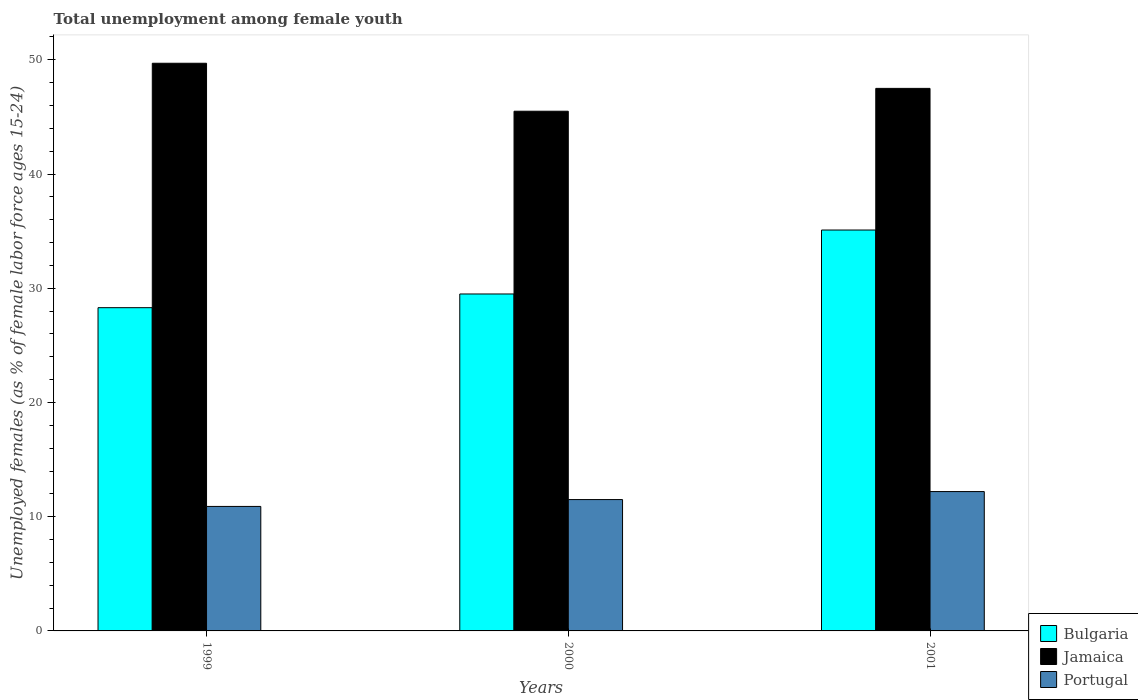How many different coloured bars are there?
Give a very brief answer. 3. Are the number of bars per tick equal to the number of legend labels?
Ensure brevity in your answer.  Yes. Are the number of bars on each tick of the X-axis equal?
Give a very brief answer. Yes. How many bars are there on the 2nd tick from the left?
Provide a short and direct response. 3. How many bars are there on the 1st tick from the right?
Your response must be concise. 3. In how many cases, is the number of bars for a given year not equal to the number of legend labels?
Your response must be concise. 0. What is the percentage of unemployed females in in Bulgaria in 2001?
Provide a short and direct response. 35.1. Across all years, what is the maximum percentage of unemployed females in in Bulgaria?
Your response must be concise. 35.1. Across all years, what is the minimum percentage of unemployed females in in Portugal?
Keep it short and to the point. 10.9. In which year was the percentage of unemployed females in in Jamaica maximum?
Offer a terse response. 1999. What is the total percentage of unemployed females in in Bulgaria in the graph?
Your response must be concise. 92.9. What is the difference between the percentage of unemployed females in in Portugal in 2000 and that in 2001?
Your answer should be compact. -0.7. What is the difference between the percentage of unemployed females in in Jamaica in 2000 and the percentage of unemployed females in in Bulgaria in 2001?
Provide a short and direct response. 10.4. What is the average percentage of unemployed females in in Portugal per year?
Keep it short and to the point. 11.53. In the year 2001, what is the difference between the percentage of unemployed females in in Bulgaria and percentage of unemployed females in in Jamaica?
Give a very brief answer. -12.4. What is the ratio of the percentage of unemployed females in in Bulgaria in 2000 to that in 2001?
Your answer should be very brief. 0.84. Is the percentage of unemployed females in in Portugal in 1999 less than that in 2000?
Offer a very short reply. Yes. What is the difference between the highest and the second highest percentage of unemployed females in in Bulgaria?
Your response must be concise. 5.6. What is the difference between the highest and the lowest percentage of unemployed females in in Portugal?
Provide a succinct answer. 1.3. In how many years, is the percentage of unemployed females in in Jamaica greater than the average percentage of unemployed females in in Jamaica taken over all years?
Provide a short and direct response. 1. Does the graph contain any zero values?
Your answer should be compact. No. Where does the legend appear in the graph?
Your response must be concise. Bottom right. How are the legend labels stacked?
Your response must be concise. Vertical. What is the title of the graph?
Provide a succinct answer. Total unemployment among female youth. Does "El Salvador" appear as one of the legend labels in the graph?
Provide a succinct answer. No. What is the label or title of the X-axis?
Your answer should be very brief. Years. What is the label or title of the Y-axis?
Provide a succinct answer. Unemployed females (as % of female labor force ages 15-24). What is the Unemployed females (as % of female labor force ages 15-24) in Bulgaria in 1999?
Your response must be concise. 28.3. What is the Unemployed females (as % of female labor force ages 15-24) in Jamaica in 1999?
Provide a succinct answer. 49.7. What is the Unemployed females (as % of female labor force ages 15-24) in Portugal in 1999?
Offer a very short reply. 10.9. What is the Unemployed females (as % of female labor force ages 15-24) of Bulgaria in 2000?
Provide a succinct answer. 29.5. What is the Unemployed females (as % of female labor force ages 15-24) in Jamaica in 2000?
Your response must be concise. 45.5. What is the Unemployed females (as % of female labor force ages 15-24) in Bulgaria in 2001?
Offer a very short reply. 35.1. What is the Unemployed females (as % of female labor force ages 15-24) of Jamaica in 2001?
Your answer should be very brief. 47.5. What is the Unemployed females (as % of female labor force ages 15-24) in Portugal in 2001?
Offer a very short reply. 12.2. Across all years, what is the maximum Unemployed females (as % of female labor force ages 15-24) in Bulgaria?
Ensure brevity in your answer.  35.1. Across all years, what is the maximum Unemployed females (as % of female labor force ages 15-24) of Jamaica?
Offer a terse response. 49.7. Across all years, what is the maximum Unemployed females (as % of female labor force ages 15-24) of Portugal?
Your response must be concise. 12.2. Across all years, what is the minimum Unemployed females (as % of female labor force ages 15-24) of Bulgaria?
Offer a terse response. 28.3. Across all years, what is the minimum Unemployed females (as % of female labor force ages 15-24) in Jamaica?
Keep it short and to the point. 45.5. Across all years, what is the minimum Unemployed females (as % of female labor force ages 15-24) of Portugal?
Offer a very short reply. 10.9. What is the total Unemployed females (as % of female labor force ages 15-24) of Bulgaria in the graph?
Provide a succinct answer. 92.9. What is the total Unemployed females (as % of female labor force ages 15-24) in Jamaica in the graph?
Give a very brief answer. 142.7. What is the total Unemployed females (as % of female labor force ages 15-24) in Portugal in the graph?
Make the answer very short. 34.6. What is the difference between the Unemployed females (as % of female labor force ages 15-24) in Jamaica in 1999 and that in 2000?
Make the answer very short. 4.2. What is the difference between the Unemployed females (as % of female labor force ages 15-24) in Portugal in 1999 and that in 2000?
Provide a succinct answer. -0.6. What is the difference between the Unemployed females (as % of female labor force ages 15-24) of Bulgaria in 2000 and that in 2001?
Make the answer very short. -5.6. What is the difference between the Unemployed females (as % of female labor force ages 15-24) in Jamaica in 2000 and that in 2001?
Your response must be concise. -2. What is the difference between the Unemployed females (as % of female labor force ages 15-24) in Bulgaria in 1999 and the Unemployed females (as % of female labor force ages 15-24) in Jamaica in 2000?
Keep it short and to the point. -17.2. What is the difference between the Unemployed females (as % of female labor force ages 15-24) of Jamaica in 1999 and the Unemployed females (as % of female labor force ages 15-24) of Portugal in 2000?
Your answer should be very brief. 38.2. What is the difference between the Unemployed females (as % of female labor force ages 15-24) of Bulgaria in 1999 and the Unemployed females (as % of female labor force ages 15-24) of Jamaica in 2001?
Make the answer very short. -19.2. What is the difference between the Unemployed females (as % of female labor force ages 15-24) of Jamaica in 1999 and the Unemployed females (as % of female labor force ages 15-24) of Portugal in 2001?
Keep it short and to the point. 37.5. What is the difference between the Unemployed females (as % of female labor force ages 15-24) of Bulgaria in 2000 and the Unemployed females (as % of female labor force ages 15-24) of Jamaica in 2001?
Ensure brevity in your answer.  -18. What is the difference between the Unemployed females (as % of female labor force ages 15-24) of Jamaica in 2000 and the Unemployed females (as % of female labor force ages 15-24) of Portugal in 2001?
Offer a terse response. 33.3. What is the average Unemployed females (as % of female labor force ages 15-24) of Bulgaria per year?
Make the answer very short. 30.97. What is the average Unemployed females (as % of female labor force ages 15-24) in Jamaica per year?
Make the answer very short. 47.57. What is the average Unemployed females (as % of female labor force ages 15-24) of Portugal per year?
Provide a succinct answer. 11.53. In the year 1999, what is the difference between the Unemployed females (as % of female labor force ages 15-24) of Bulgaria and Unemployed females (as % of female labor force ages 15-24) of Jamaica?
Provide a short and direct response. -21.4. In the year 1999, what is the difference between the Unemployed females (as % of female labor force ages 15-24) in Jamaica and Unemployed females (as % of female labor force ages 15-24) in Portugal?
Your response must be concise. 38.8. In the year 2001, what is the difference between the Unemployed females (as % of female labor force ages 15-24) in Bulgaria and Unemployed females (as % of female labor force ages 15-24) in Portugal?
Make the answer very short. 22.9. In the year 2001, what is the difference between the Unemployed females (as % of female labor force ages 15-24) of Jamaica and Unemployed females (as % of female labor force ages 15-24) of Portugal?
Offer a very short reply. 35.3. What is the ratio of the Unemployed females (as % of female labor force ages 15-24) of Bulgaria in 1999 to that in 2000?
Your response must be concise. 0.96. What is the ratio of the Unemployed females (as % of female labor force ages 15-24) in Jamaica in 1999 to that in 2000?
Provide a succinct answer. 1.09. What is the ratio of the Unemployed females (as % of female labor force ages 15-24) of Portugal in 1999 to that in 2000?
Make the answer very short. 0.95. What is the ratio of the Unemployed females (as % of female labor force ages 15-24) of Bulgaria in 1999 to that in 2001?
Keep it short and to the point. 0.81. What is the ratio of the Unemployed females (as % of female labor force ages 15-24) in Jamaica in 1999 to that in 2001?
Ensure brevity in your answer.  1.05. What is the ratio of the Unemployed females (as % of female labor force ages 15-24) in Portugal in 1999 to that in 2001?
Offer a very short reply. 0.89. What is the ratio of the Unemployed females (as % of female labor force ages 15-24) of Bulgaria in 2000 to that in 2001?
Ensure brevity in your answer.  0.84. What is the ratio of the Unemployed females (as % of female labor force ages 15-24) of Jamaica in 2000 to that in 2001?
Offer a terse response. 0.96. What is the ratio of the Unemployed females (as % of female labor force ages 15-24) of Portugal in 2000 to that in 2001?
Offer a terse response. 0.94. What is the difference between the highest and the second highest Unemployed females (as % of female labor force ages 15-24) of Jamaica?
Your answer should be very brief. 2.2. What is the difference between the highest and the lowest Unemployed females (as % of female labor force ages 15-24) of Portugal?
Give a very brief answer. 1.3. 